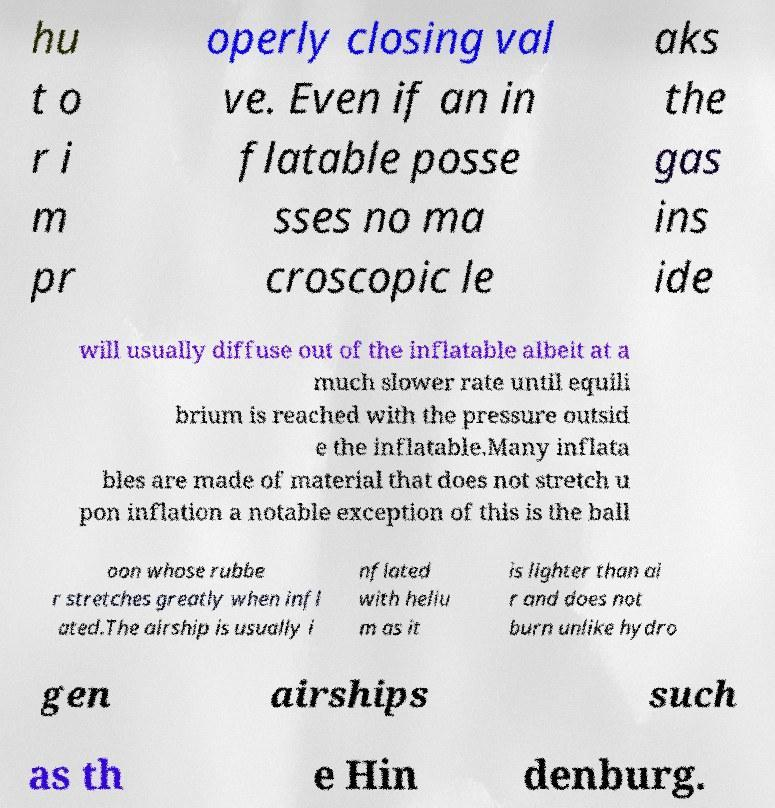Can you accurately transcribe the text from the provided image for me? hu t o r i m pr operly closing val ve. Even if an in flatable posse sses no ma croscopic le aks the gas ins ide will usually diffuse out of the inflatable albeit at a much slower rate until equili brium is reached with the pressure outsid e the inflatable.Many inflata bles are made of material that does not stretch u pon inflation a notable exception of this is the ball oon whose rubbe r stretches greatly when infl ated.The airship is usually i nflated with heliu m as it is lighter than ai r and does not burn unlike hydro gen airships such as th e Hin denburg. 